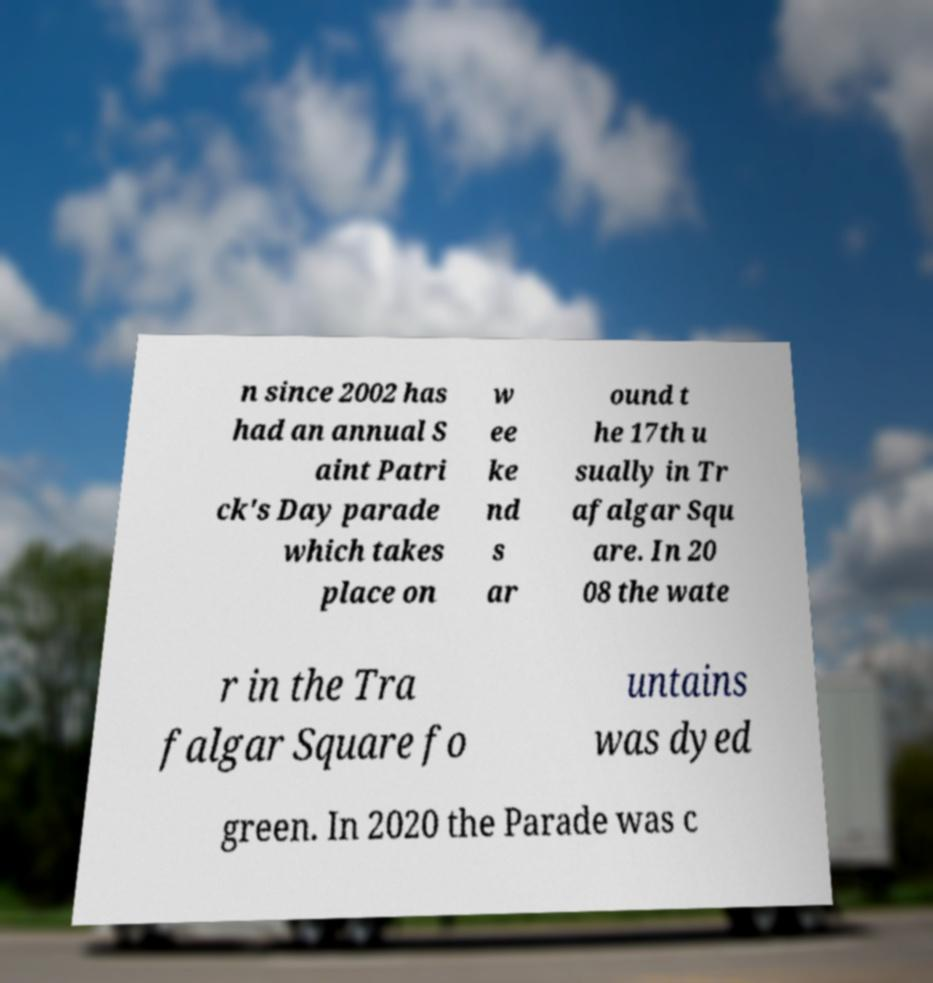I need the written content from this picture converted into text. Can you do that? n since 2002 has had an annual S aint Patri ck's Day parade which takes place on w ee ke nd s ar ound t he 17th u sually in Tr afalgar Squ are. In 20 08 the wate r in the Tra falgar Square fo untains was dyed green. In 2020 the Parade was c 